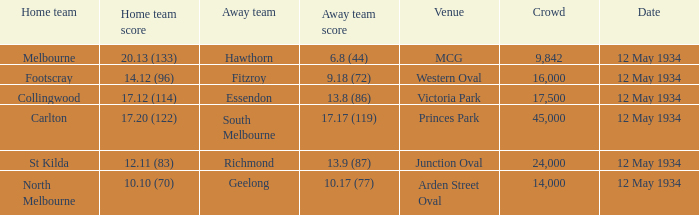What was the score of the away team while playing at the arden street oval? 10.17 (77). 